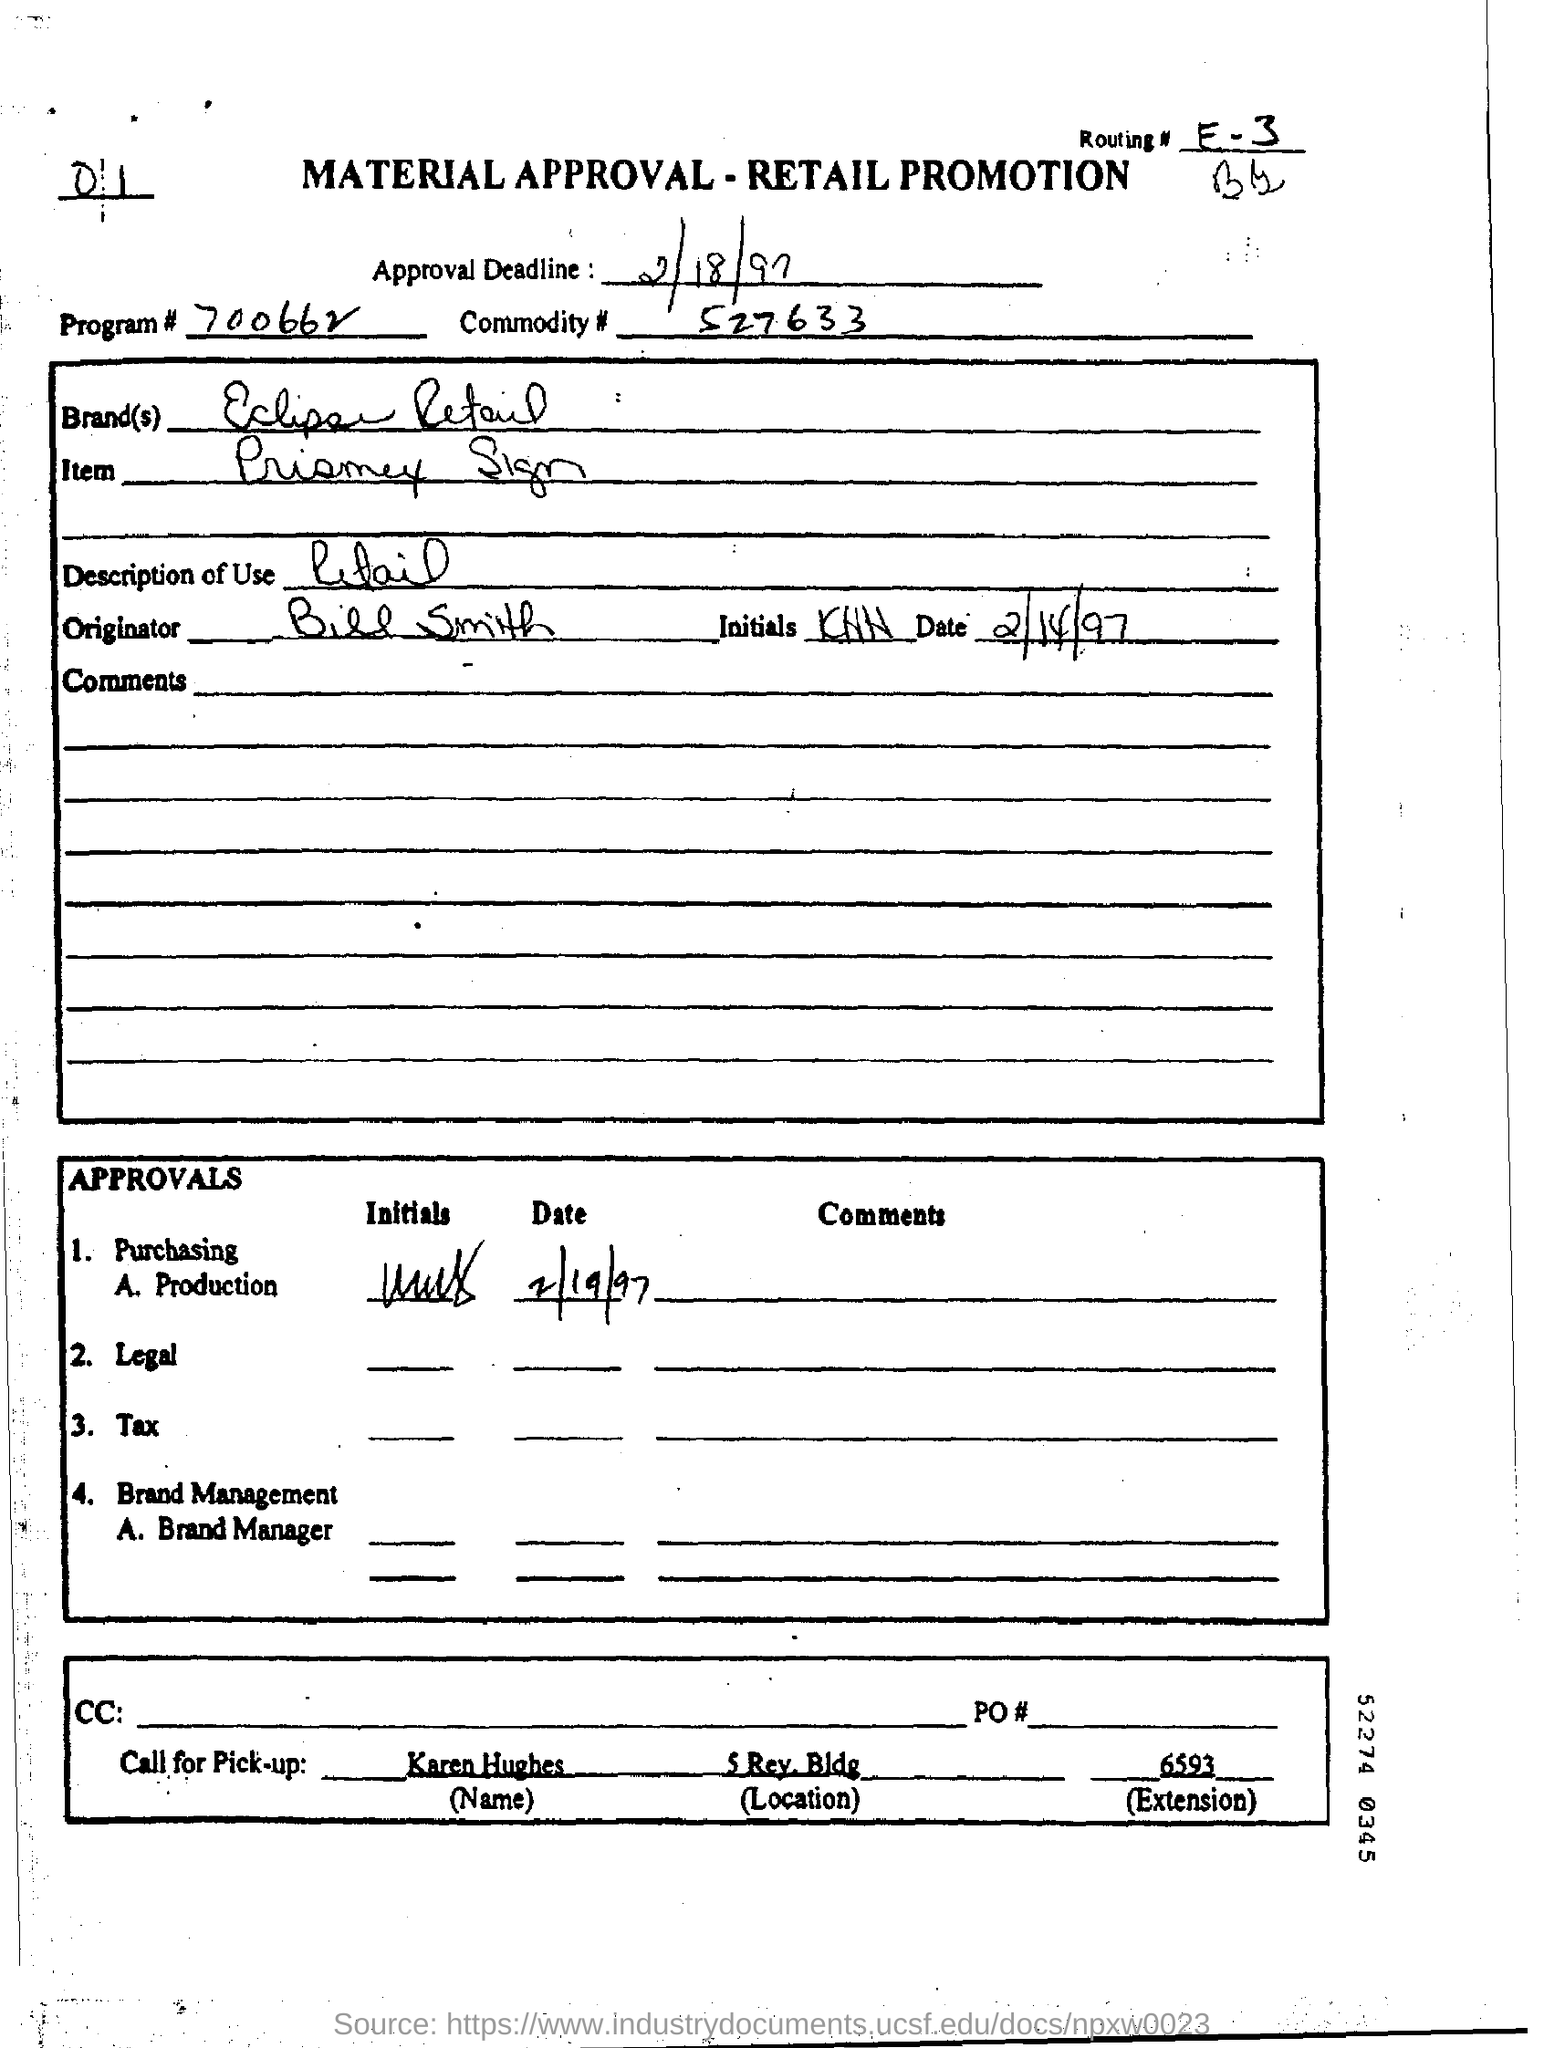Mention a couple of crucial points in this snapshot. Karen Hughes will answer the call for pick-up," the declaration reads. Eclipse Retail is the brand name. What is the Program Number? It is 700662... I, Bill Smith, am the originator. The description of use is retail. 